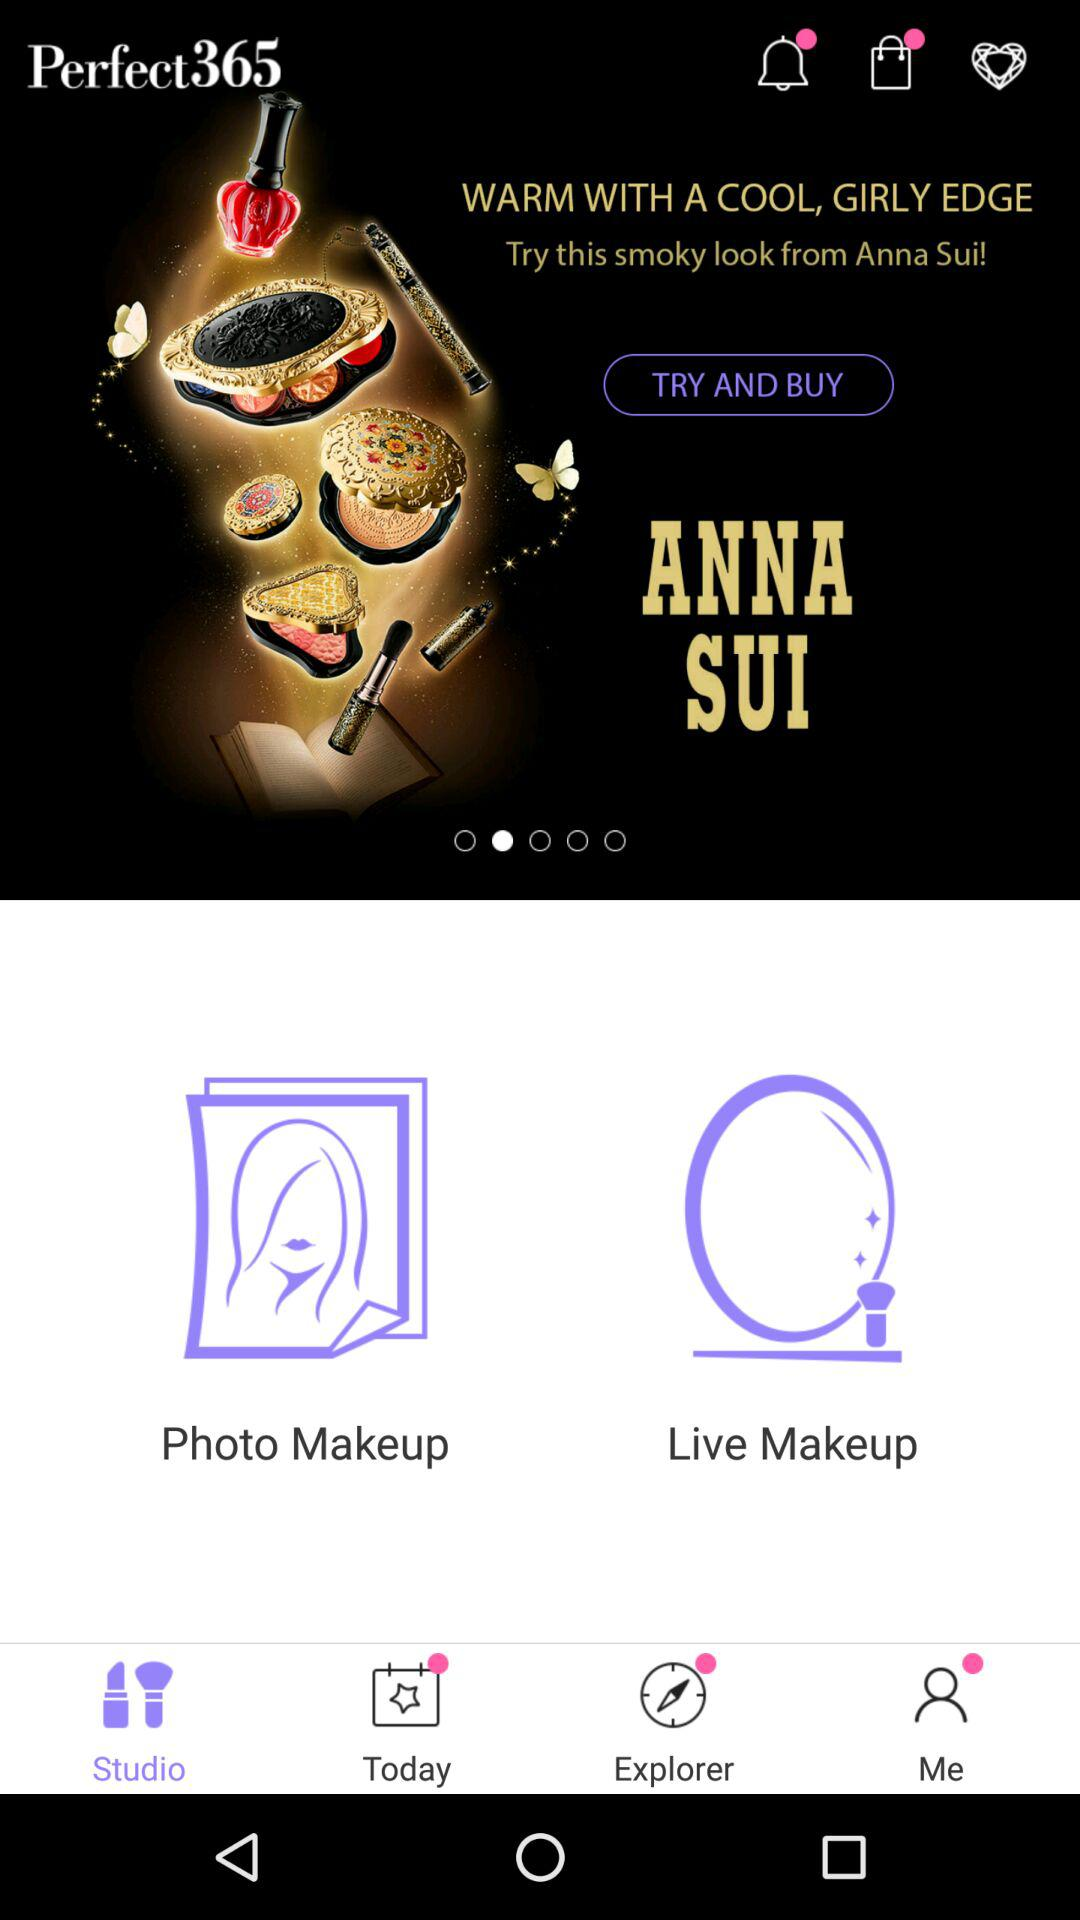How many makeup looks are available?
Answer the question using a single word or phrase. 2 